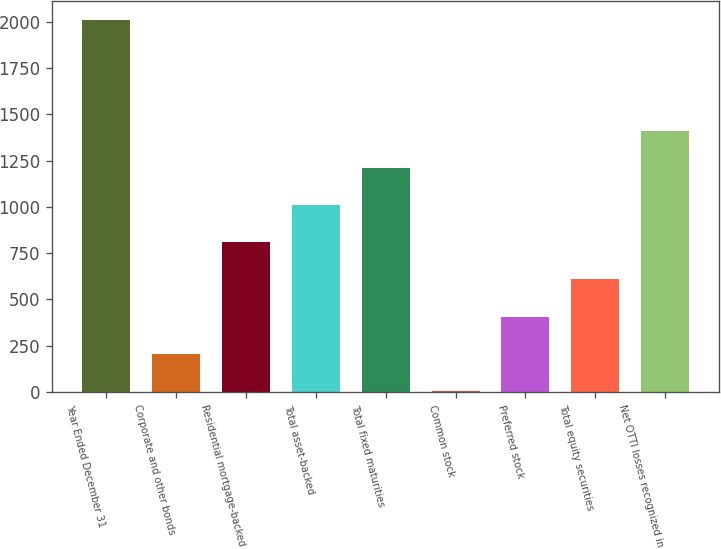Convert chart. <chart><loc_0><loc_0><loc_500><loc_500><bar_chart><fcel>Year Ended December 31<fcel>Corporate and other bonds<fcel>Residential mortgage-backed<fcel>Total asset-backed<fcel>Total fixed maturities<fcel>Common stock<fcel>Preferred stock<fcel>Total equity securities<fcel>Net OTTI losses recognized in<nl><fcel>2012<fcel>206.6<fcel>808.4<fcel>1009<fcel>1209.6<fcel>6<fcel>407.2<fcel>607.8<fcel>1410.2<nl></chart> 